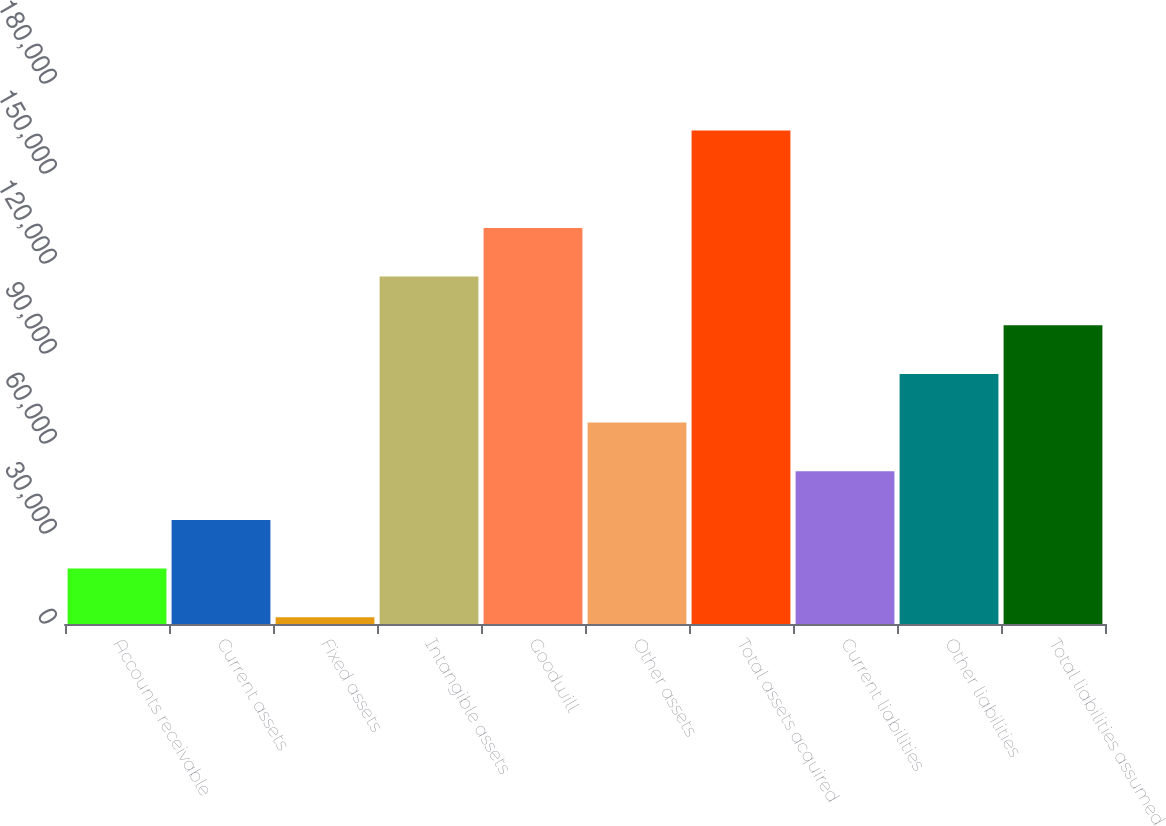<chart> <loc_0><loc_0><loc_500><loc_500><bar_chart><fcel>Accounts receivable<fcel>Current assets<fcel>Fixed assets<fcel>Intangible assets<fcel>Goodwill<fcel>Other assets<fcel>Total assets acquired<fcel>Current liabilities<fcel>Other liabilities<fcel>Total liabilities assumed<nl><fcel>18460.1<fcel>34682.2<fcel>2238<fcel>115793<fcel>132015<fcel>67126.4<fcel>164459<fcel>50904.3<fcel>83348.5<fcel>99570.6<nl></chart> 